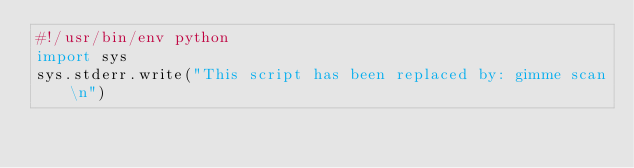Convert code to text. <code><loc_0><loc_0><loc_500><loc_500><_Python_>#!/usr/bin/env python
import sys
sys.stderr.write("This script has been replaced by: gimme scan\n")
</code> 